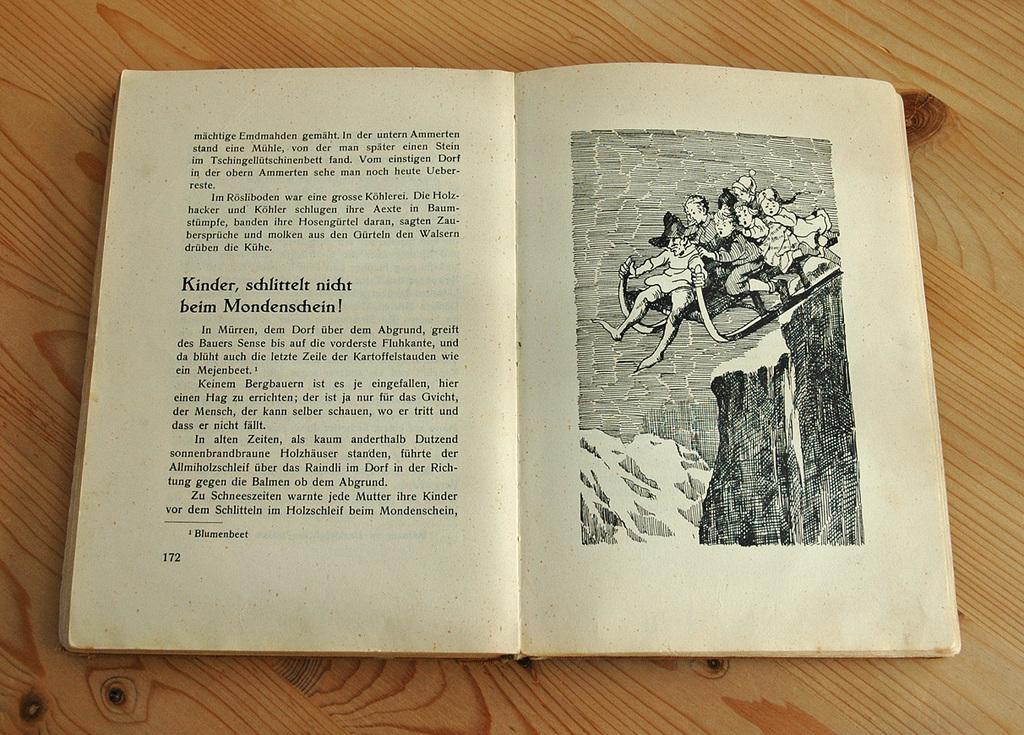Provide a one-sentence caption for the provided image. some people in a photo with words in a different language next to them. 